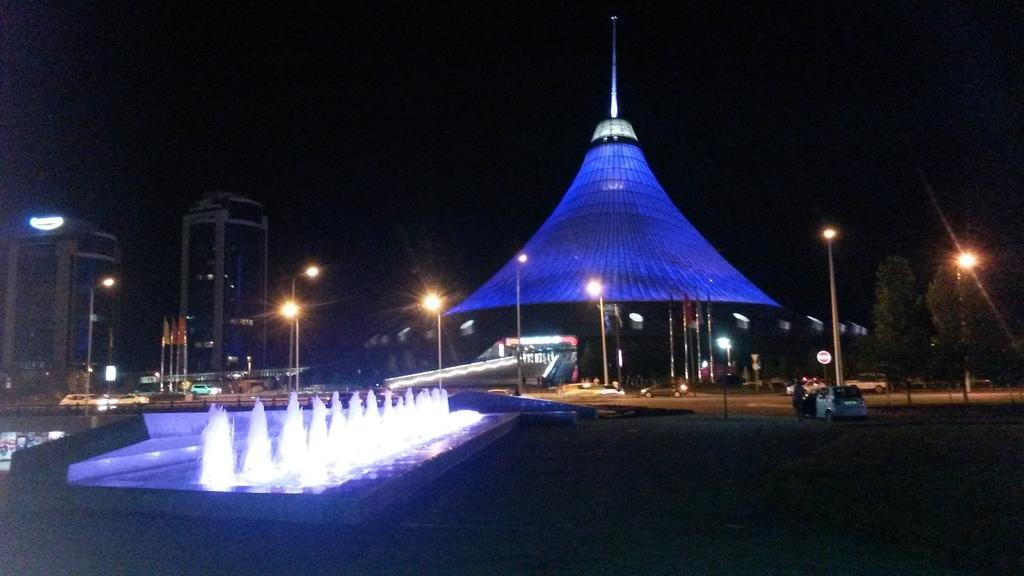Can you describe this image briefly? In this image we can see many vehicles. There are few buildings in the image. There is a fountain at the left side of the image. There are many trees in the image. There are many flags in the image. There are many street lights in the image. We can see the dark sky in the image. 